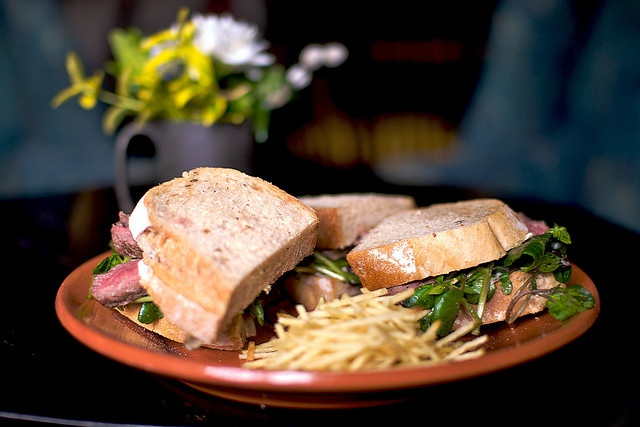Describe the objects in this image and their specific colors. I can see potted plant in navy, black, gray, and olive tones, sandwich in navy, lightgray, tan, and black tones, sandwich in navy, black, darkgreen, and tan tones, sandwich in navy, tan, black, gray, and maroon tones, and cup in navy, gray, and black tones in this image. 